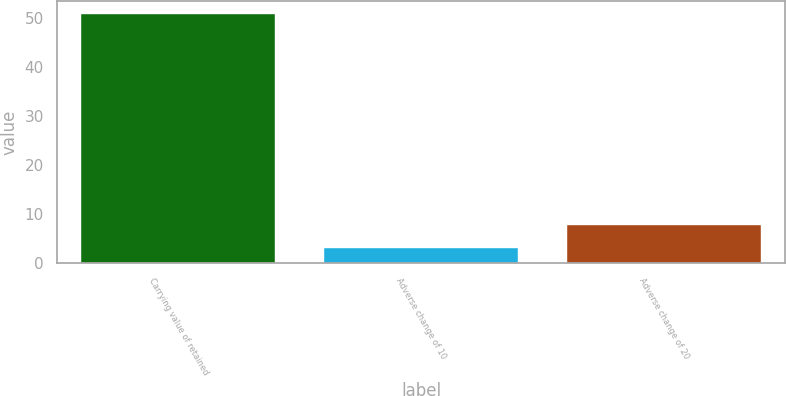<chart> <loc_0><loc_0><loc_500><loc_500><bar_chart><fcel>Carrying value of retained<fcel>Adverse change of 10<fcel>Adverse change of 20<nl><fcel>51<fcel>3<fcel>7.8<nl></chart> 